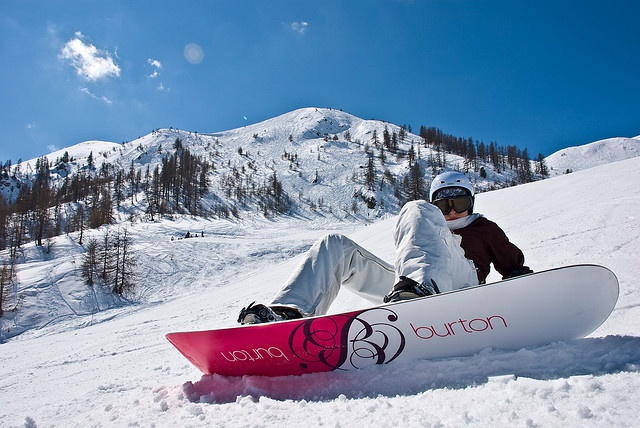Describe the objects in this image and their specific colors. I can see snowboard in gray, darkgray, and brown tones, people in gray, darkgray, black, and lightgray tones, people in gray, black, darkblue, and teal tones, people in gray, darkgray, and black tones, and people in gray, black, and darkgray tones in this image. 